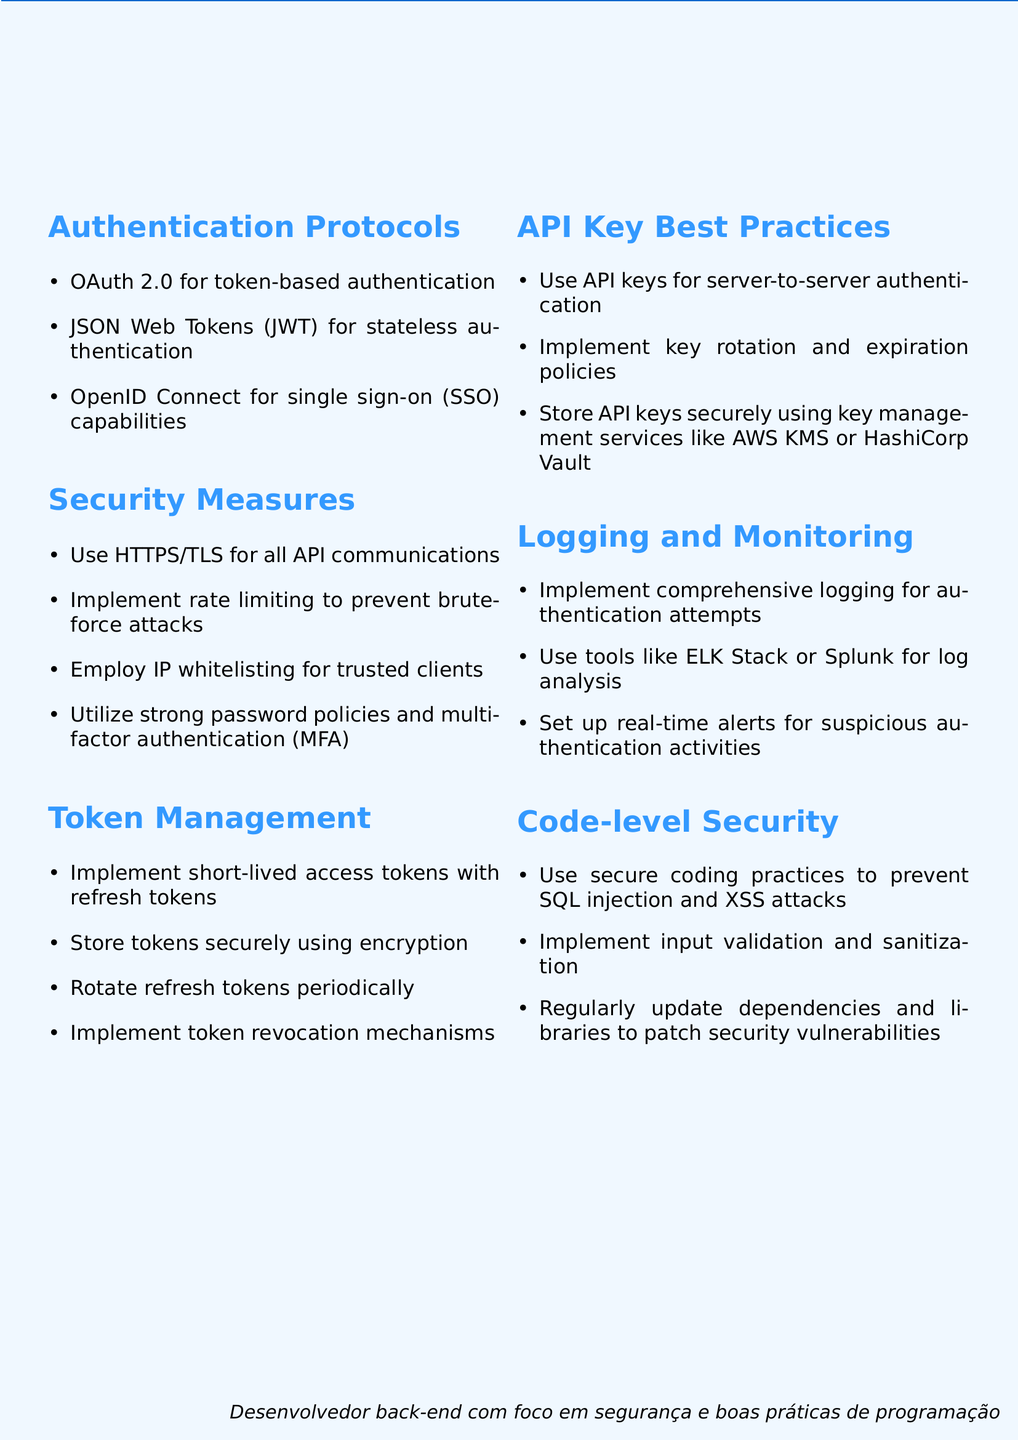What protocol is used for token-based authentication? The document states that OAuth 2.0 is used for token-based authentication.
Answer: OAuth 2.0 What is one of the practices for securing API communications? The document mentions using HTTPS/TLS as a security measure for API communications.
Answer: HTTPS/TLS What does the document suggest implementing to prevent brute-force attacks? The document recommends implementing rate limiting as a security measure against brute-force attacks.
Answer: Rate limiting What type of tokens should be used for access management? According to the document, short-lived access tokens with refresh tokens should be implemented for token management.
Answer: Short-lived access tokens What is one best practice for storing API keys? The document recommends using key management services like AWS KMS or HashiCorp Vault for securely storing API keys.
Answer: Key management services What is suggested for analyzing logs? The document suggests using tools like ELK Stack or Splunk for log analysis.
Answer: ELK Stack or Splunk How often should refresh tokens be rotated? The document recommends periodically rotating refresh tokens.
Answer: Periodically What coding practice is important to prevent SQL injection? The document emphasizes the use of secure coding practices to prevent SQL injection.
Answer: Secure coding practices 